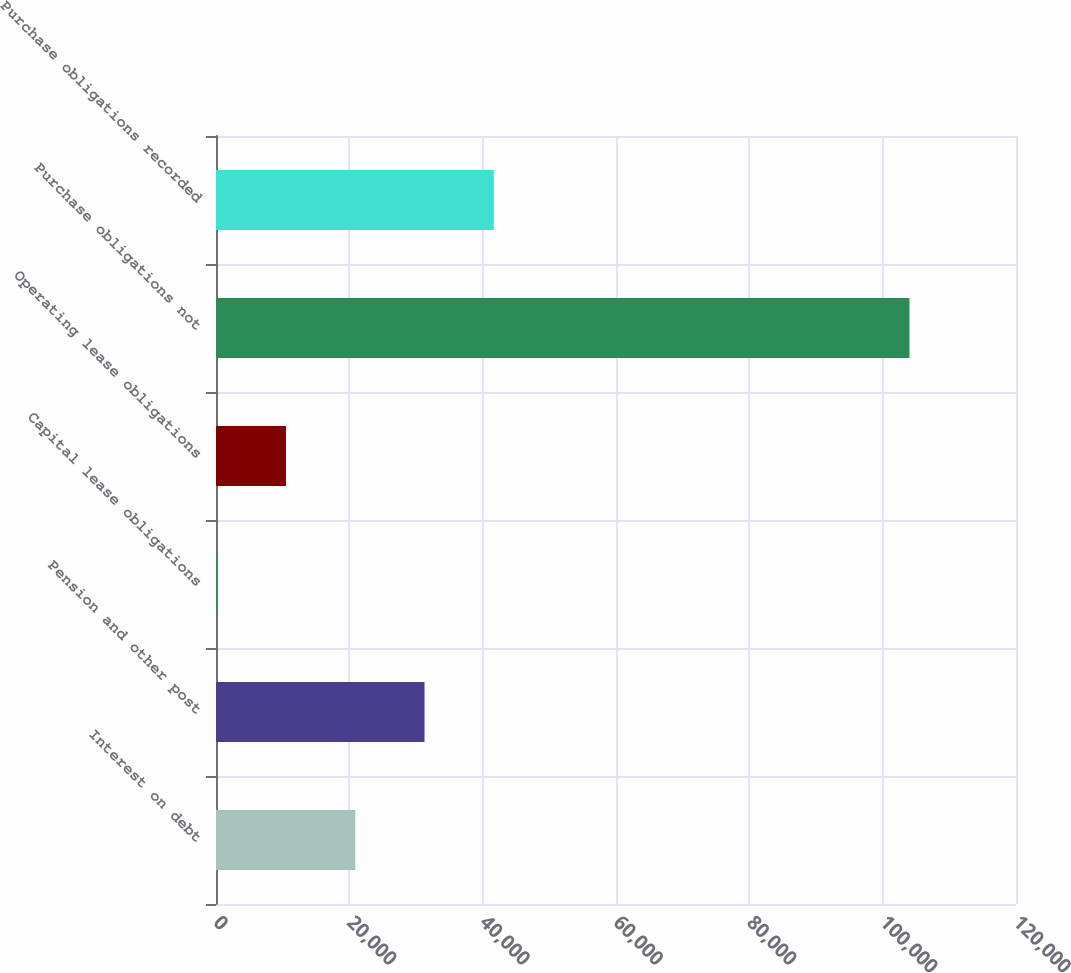Convert chart. <chart><loc_0><loc_0><loc_500><loc_500><bar_chart><fcel>Interest on debt<fcel>Pension and other post<fcel>Capital lease obligations<fcel>Operating lease obligations<fcel>Purchase obligations not<fcel>Purchase obligations recorded<nl><fcel>20887<fcel>31279<fcel>103<fcel>10495<fcel>104023<fcel>41671<nl></chart> 